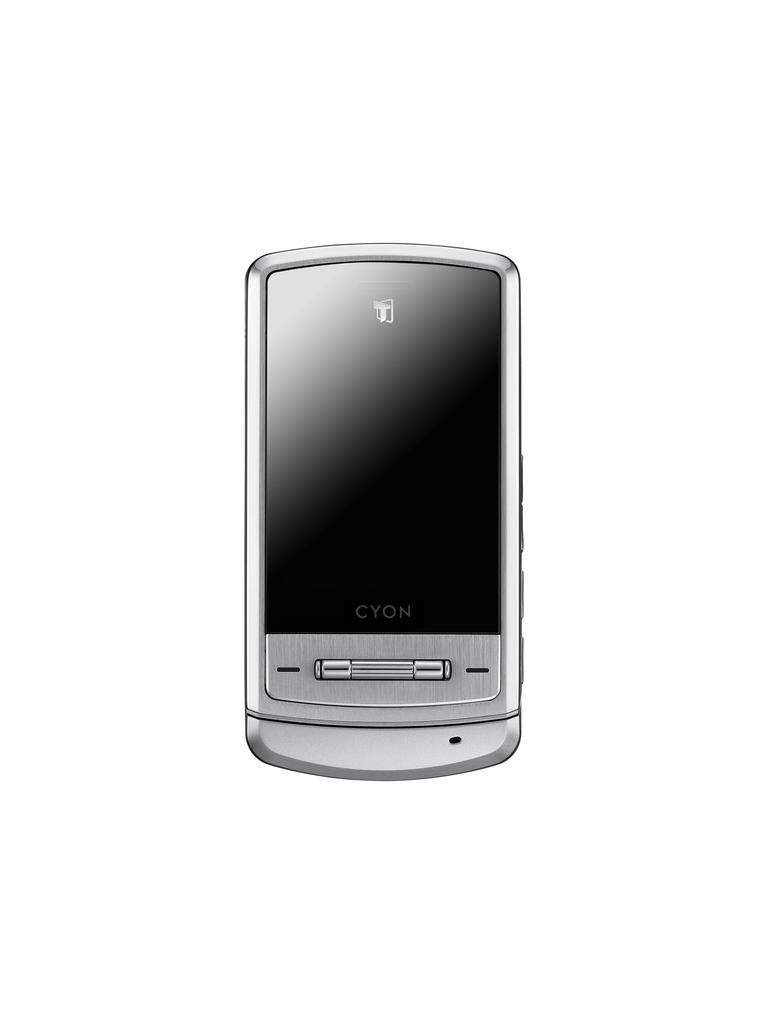<image>
Describe the image concisely. A silver CYON phone with a black screen lays on a white background. 